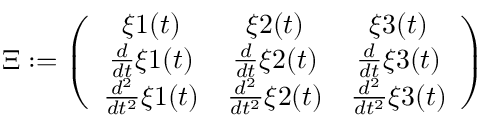<formula> <loc_0><loc_0><loc_500><loc_500>\Xi \colon = \left ( \begin{array} { c c c } { \xi { 1 } ( t ) } & { \xi { 2 } ( t ) } & { \xi { 3 } ( t ) } \\ { \frac { d } { d t } \xi { 1 } ( t ) } & { \frac { d } { d t } \xi { 2 } ( t ) } & { \frac { d } { d t } \xi { 3 } ( t ) } \\ { \frac { d ^ { 2 } } { d t ^ { 2 } } \xi { 1 } ( t ) } & { \frac { d ^ { 2 } } { d t ^ { 2 } } \xi { 2 } ( t ) } & { \frac { d ^ { 2 } } { d t ^ { 2 } } \xi { 3 } ( t ) } \end{array} \right )</formula> 